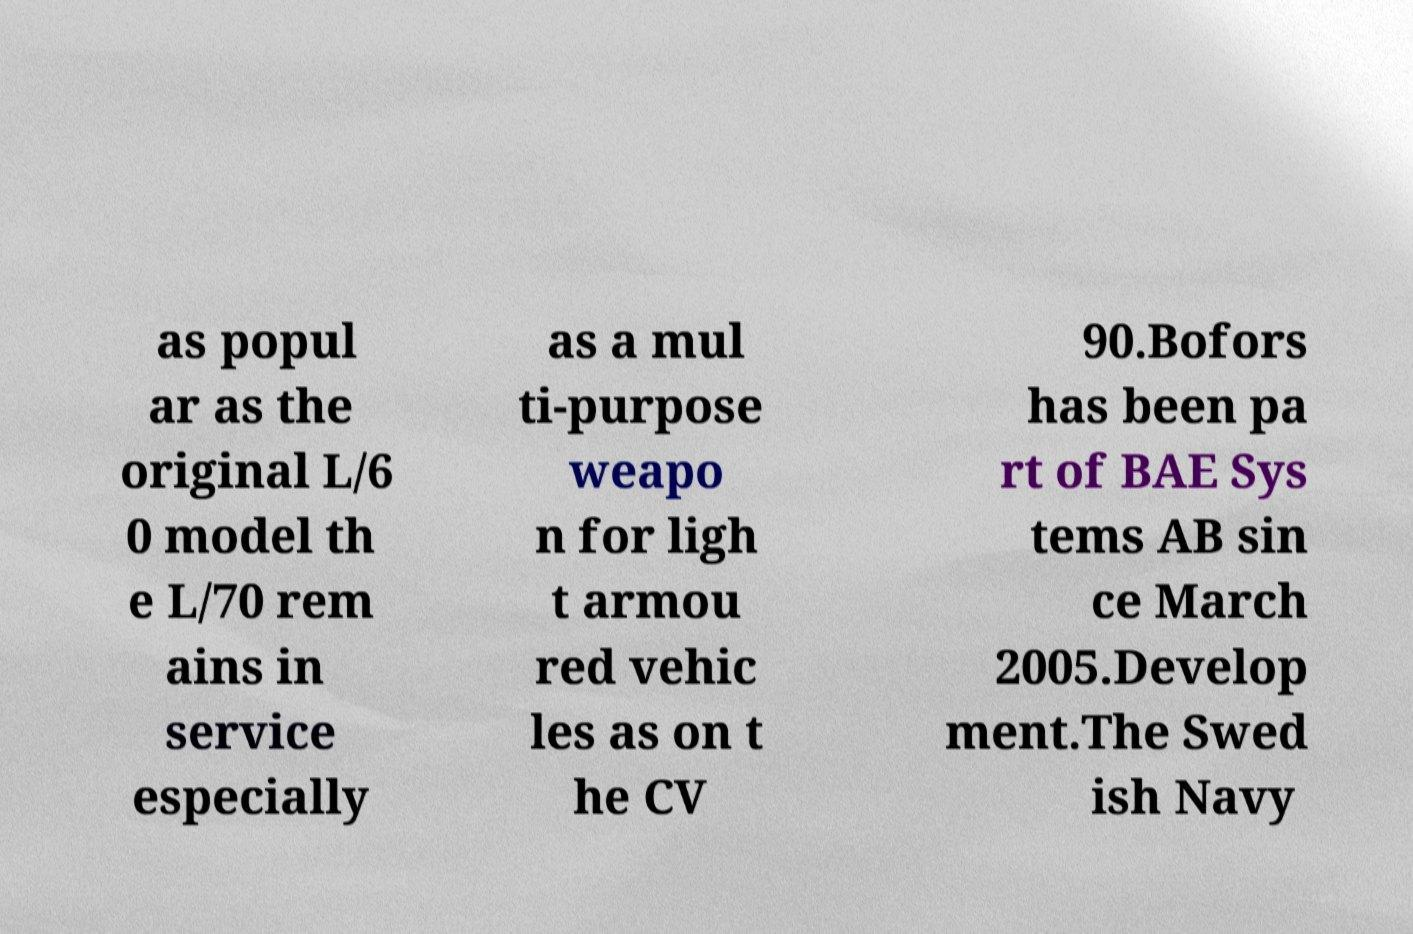Can you read and provide the text displayed in the image?This photo seems to have some interesting text. Can you extract and type it out for me? as popul ar as the original L/6 0 model th e L/70 rem ains in service especially as a mul ti-purpose weapo n for ligh t armou red vehic les as on t he CV 90.Bofors has been pa rt of BAE Sys tems AB sin ce March 2005.Develop ment.The Swed ish Navy 